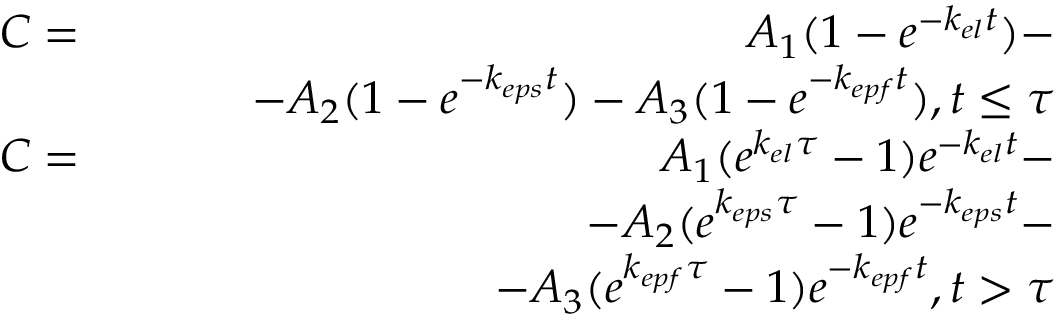<formula> <loc_0><loc_0><loc_500><loc_500>\begin{array} { r l r } & { C = } & { A _ { 1 } ( 1 - e ^ { - k _ { e l } t } ) - } \\ & { \quad - A _ { 2 } ( 1 - e ^ { - k _ { e p s } t } ) - A _ { 3 } ( 1 - e ^ { - k _ { e p f } t } ) , t \leq \tau } \\ & { C = } & { A _ { 1 } ( e ^ { k _ { e l } \tau } - 1 ) e ^ { - k _ { e l } t } - } \\ & { \quad - A _ { 2 } ( e ^ { k _ { e p s } \tau } - 1 ) e ^ { - k _ { e p s } t } - } \\ & { \quad - A _ { 3 } ( e ^ { k _ { e p f } \tau } - 1 ) e ^ { - k _ { e p f } t } , t > \tau } \end{array}</formula> 